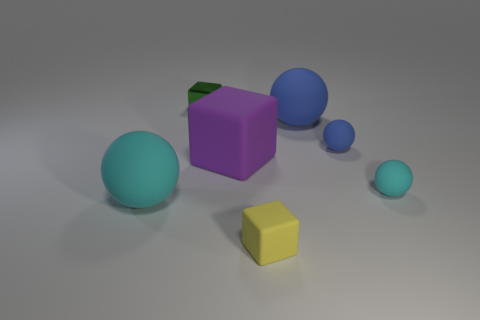Subtract 1 spheres. How many spheres are left? 3 Add 1 large blue rubber objects. How many objects exist? 8 Subtract all cubes. How many objects are left? 4 Add 2 small cyan spheres. How many small cyan spheres are left? 3 Add 6 big spheres. How many big spheres exist? 8 Subtract 0 blue blocks. How many objects are left? 7 Subtract all green cubes. Subtract all small blocks. How many objects are left? 4 